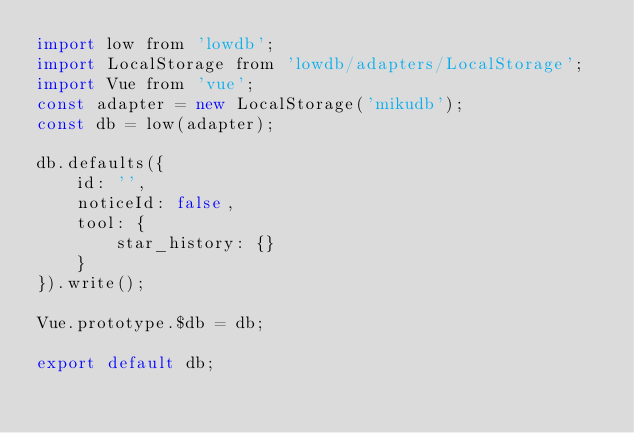<code> <loc_0><loc_0><loc_500><loc_500><_JavaScript_>import low from 'lowdb';
import LocalStorage from 'lowdb/adapters/LocalStorage';
import Vue from 'vue';
const adapter = new LocalStorage('mikudb');
const db = low(adapter);

db.defaults({
    id: '',
    noticeId: false,
    tool: {
        star_history: {}
    }
}).write();

Vue.prototype.$db = db;

export default db;
</code> 